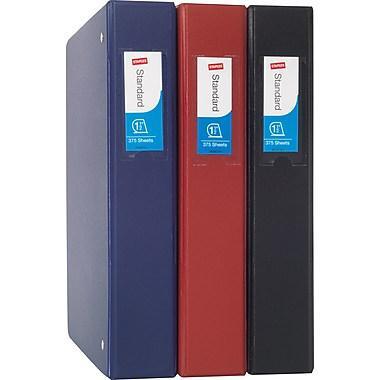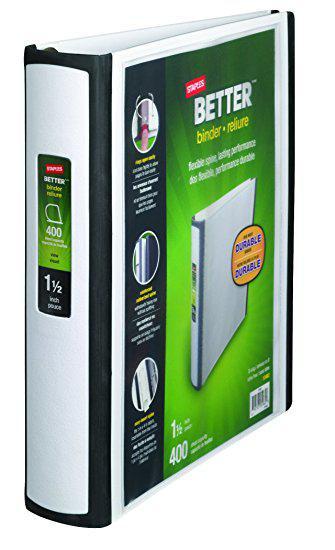The first image is the image on the left, the second image is the image on the right. For the images shown, is this caption "There is a single binder by itself." true? Answer yes or no. Yes. The first image is the image on the left, the second image is the image on the right. Considering the images on both sides, is "There are less than ten binders." valid? Answer yes or no. Yes. 